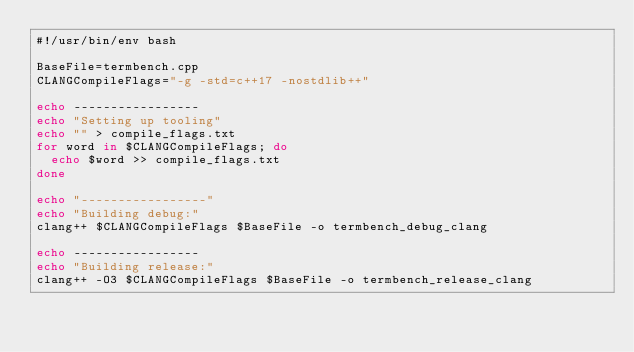<code> <loc_0><loc_0><loc_500><loc_500><_Bash_>#!/usr/bin/env bash

BaseFile=termbench.cpp
CLANGCompileFlags="-g -std=c++17 -nostdlib++"

echo -----------------
echo "Setting up tooling"
echo "" > compile_flags.txt
for word in $CLANGCompileFlags; do
  echo $word >> compile_flags.txt
done

echo "-----------------"
echo "Building debug:"
clang++ $CLANGCompileFlags $BaseFile -o termbench_debug_clang

echo -----------------
echo "Building release:"
clang++ -O3 $CLANGCompileFlags $BaseFile -o termbench_release_clang




</code> 